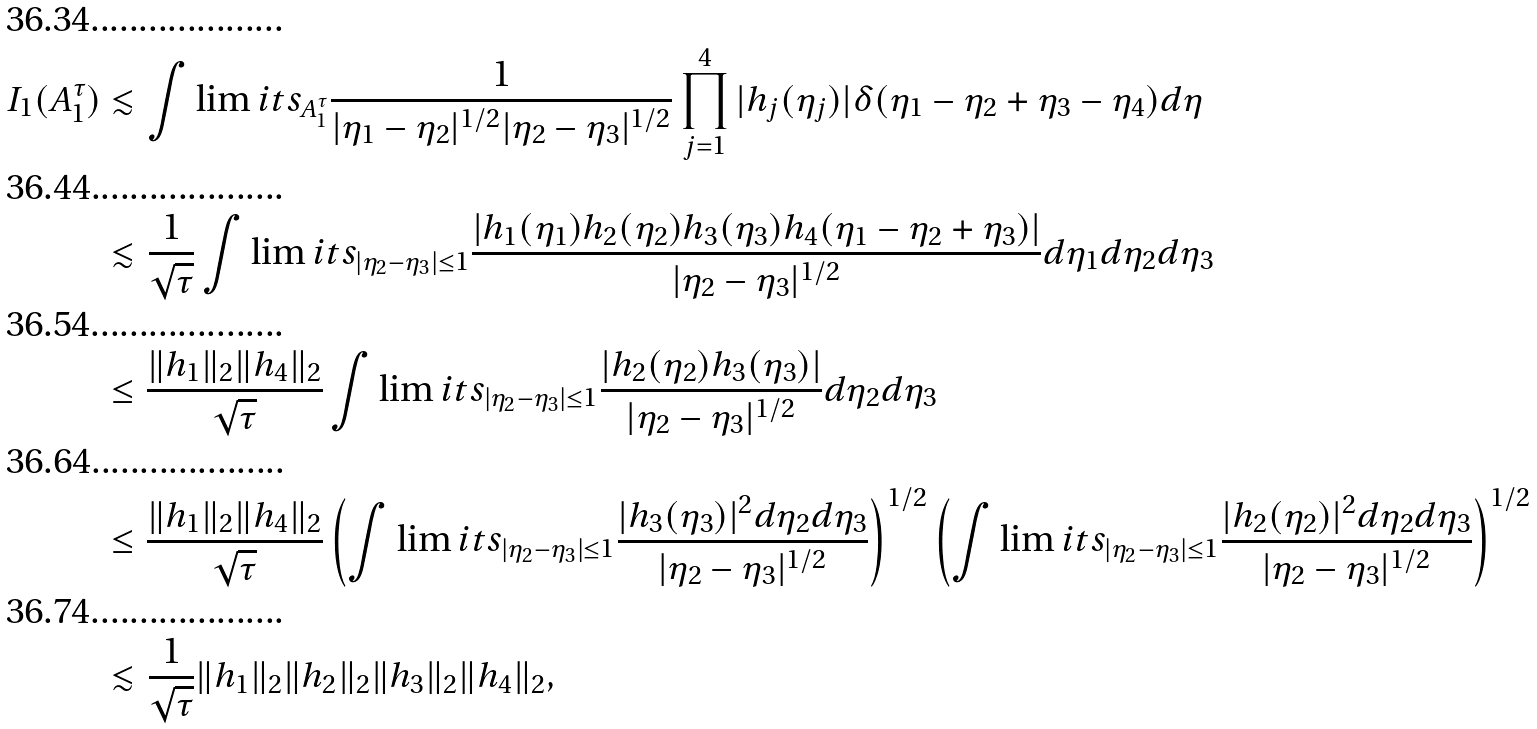<formula> <loc_0><loc_0><loc_500><loc_500>I _ { 1 } ( A _ { 1 } ^ { \tau } ) & \lesssim \int \lim i t s _ { A _ { 1 } ^ { \tau } } \frac { 1 } { | \eta _ { 1 } - \eta _ { 2 } | ^ { 1 / 2 } | \eta _ { 2 } - \eta _ { 3 } | ^ { 1 / 2 } } \prod _ { j = 1 } ^ { 4 } | h _ { j } ( \eta _ { j } ) | \delta ( \eta _ { 1 } - \eta _ { 2 } + \eta _ { 3 } - \eta _ { 4 } ) d \eta \\ & \lesssim \frac { 1 } { \sqrt { \tau } } \int \lim i t s _ { | \eta _ { 2 } - \eta _ { 3 } | \leq 1 } \frac { | h _ { 1 } ( \eta _ { 1 } ) h _ { 2 } ( \eta _ { 2 } ) h _ { 3 } ( \eta _ { 3 } ) h _ { 4 } ( \eta _ { 1 } - \eta _ { 2 } + \eta _ { 3 } ) | } { | \eta _ { 2 } - \eta _ { 3 } | ^ { 1 / 2 } } d \eta _ { 1 } d \eta _ { 2 } d \eta _ { 3 } \\ & \leq \frac { \| h _ { 1 } \| _ { 2 } \| h _ { 4 } \| _ { 2 } } { \sqrt { \tau } } \int \lim i t s _ { | \eta _ { 2 } - \eta _ { 3 } | \leq 1 } \frac { | h _ { 2 } ( \eta _ { 2 } ) h _ { 3 } ( \eta _ { 3 } ) | } { | \eta _ { 2 } - \eta _ { 3 } | ^ { 1 / 2 } } d \eta _ { 2 } d \eta _ { 3 } \\ & \leq \frac { \| h _ { 1 } \| _ { 2 } \| h _ { 4 } \| _ { 2 } } { \sqrt { \tau } } \left ( \int \lim i t s _ { | \eta _ { 2 } - \eta _ { 3 } | \leq 1 } \frac { | h _ { 3 } ( \eta _ { 3 } ) | ^ { 2 } d \eta _ { 2 } d \eta _ { 3 } } { | \eta _ { 2 } - \eta _ { 3 } | ^ { 1 / 2 } } \right ) ^ { 1 / 2 } \left ( \int \lim i t s _ { | \eta _ { 2 } - \eta _ { 3 } | \leq 1 } \frac { | h _ { 2 } ( \eta _ { 2 } ) | ^ { 2 } d \eta _ { 2 } d \eta _ { 3 } } { | \eta _ { 2 } - \eta _ { 3 } | ^ { 1 / 2 } } \right ) ^ { 1 / 2 } \\ & \lesssim \frac { 1 } { \sqrt { \tau } } \| h _ { 1 } \| _ { 2 } \| h _ { 2 } \| _ { 2 } \| h _ { 3 } \| _ { 2 } \| h _ { 4 } \| _ { 2 } ,</formula> 